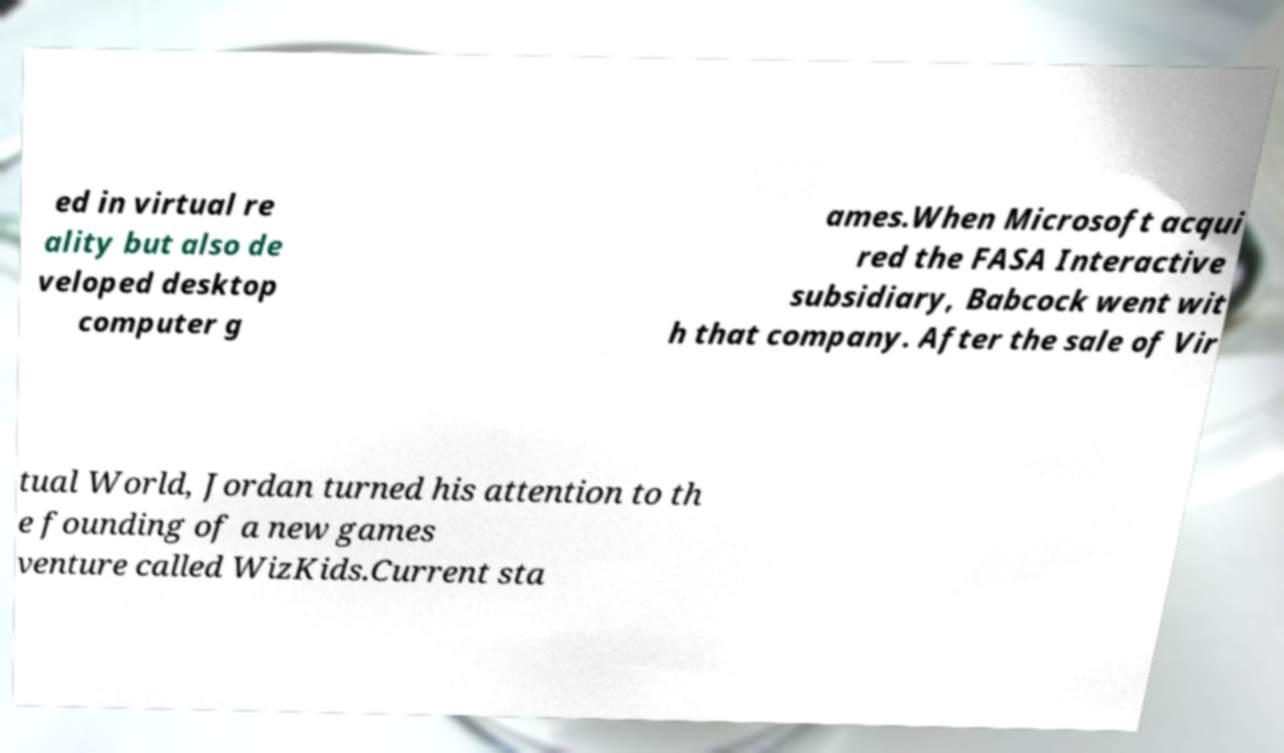Please identify and transcribe the text found in this image. ed in virtual re ality but also de veloped desktop computer g ames.When Microsoft acqui red the FASA Interactive subsidiary, Babcock went wit h that company. After the sale of Vir tual World, Jordan turned his attention to th e founding of a new games venture called WizKids.Current sta 